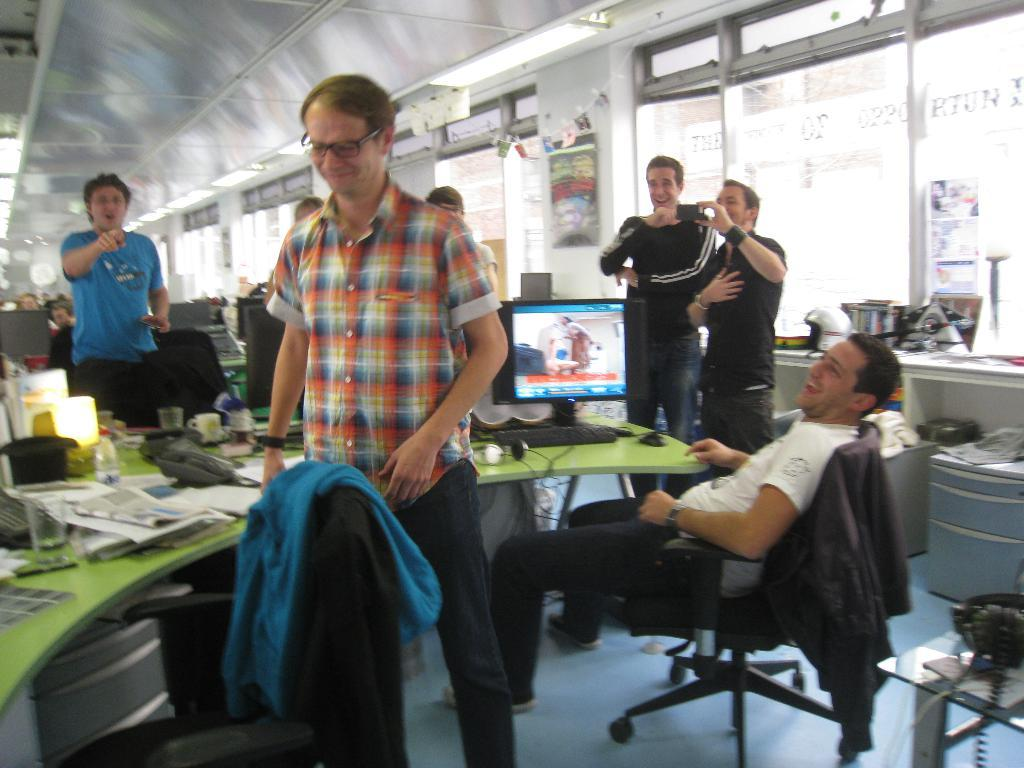Who is the main subject in the image? There is a man in the image. What is the man doing in the image? The man is standing and smiling. Are there other people in the image besides the man? Yes, there are people in the image. What are the people in the image doing? The people are also smiling and looking at the man. What type of plastic is the man holding in the image? There is no plastic object visible in the image. Can you tell me how many eyes the dog has in the image? There is no dog present in the image. 